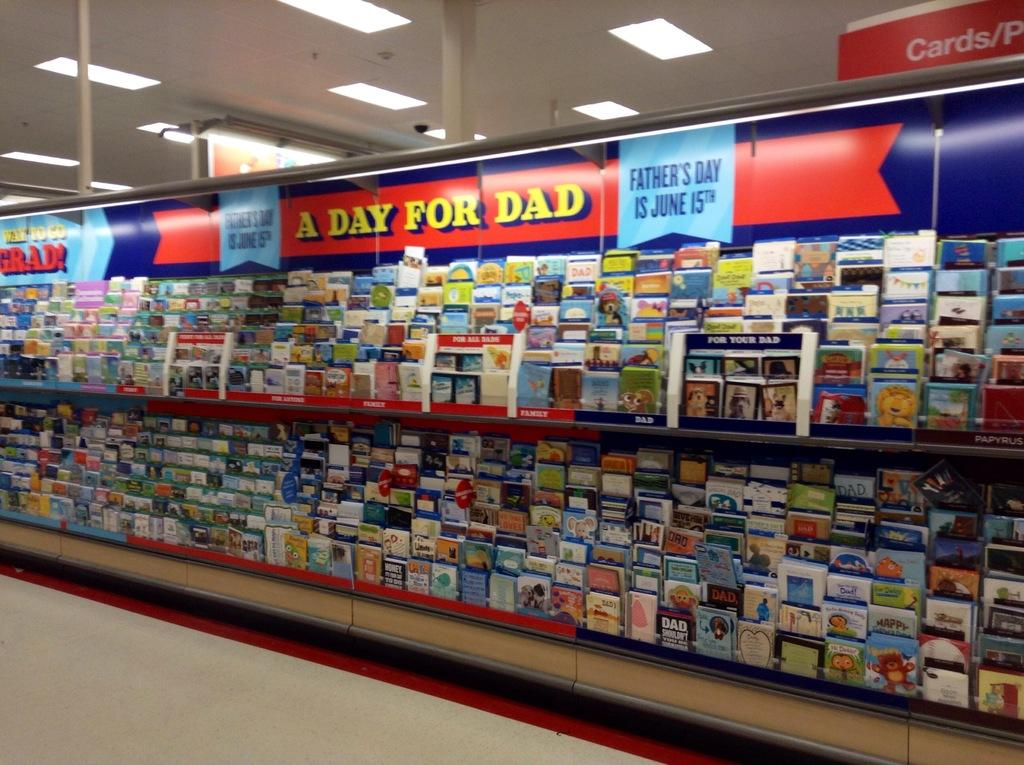<image>
Give a short and clear explanation of the subsequent image. An aisle of greeting cards with A Day for Dad written on the top. 